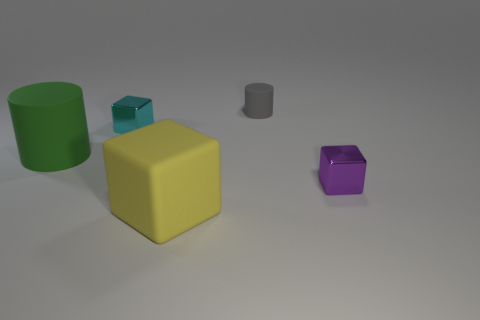What is the shape of the large object that is on the left side of the tiny shiny block that is to the left of the yellow rubber object in front of the small rubber object?
Offer a very short reply. Cylinder. Do the yellow cube and the cube to the left of the big yellow rubber cube have the same size?
Ensure brevity in your answer.  No. Is there a matte thing of the same size as the green cylinder?
Make the answer very short. Yes. How many other objects are the same material as the small gray cylinder?
Offer a terse response. 2. What color is the matte thing that is both on the right side of the big cylinder and behind the small purple shiny block?
Ensure brevity in your answer.  Gray. Is the material of the cylinder left of the tiny gray object the same as the big object in front of the purple metallic object?
Provide a short and direct response. Yes. There is a matte cylinder right of the yellow rubber thing; is its size the same as the purple shiny thing?
Your response must be concise. Yes. There is a big block; is it the same color as the tiny metal cube that is to the right of the tiny rubber cylinder?
Provide a succinct answer. No. There is a cyan thing; what shape is it?
Your response must be concise. Cube. Does the small matte thing have the same color as the big cylinder?
Your answer should be compact. No. 